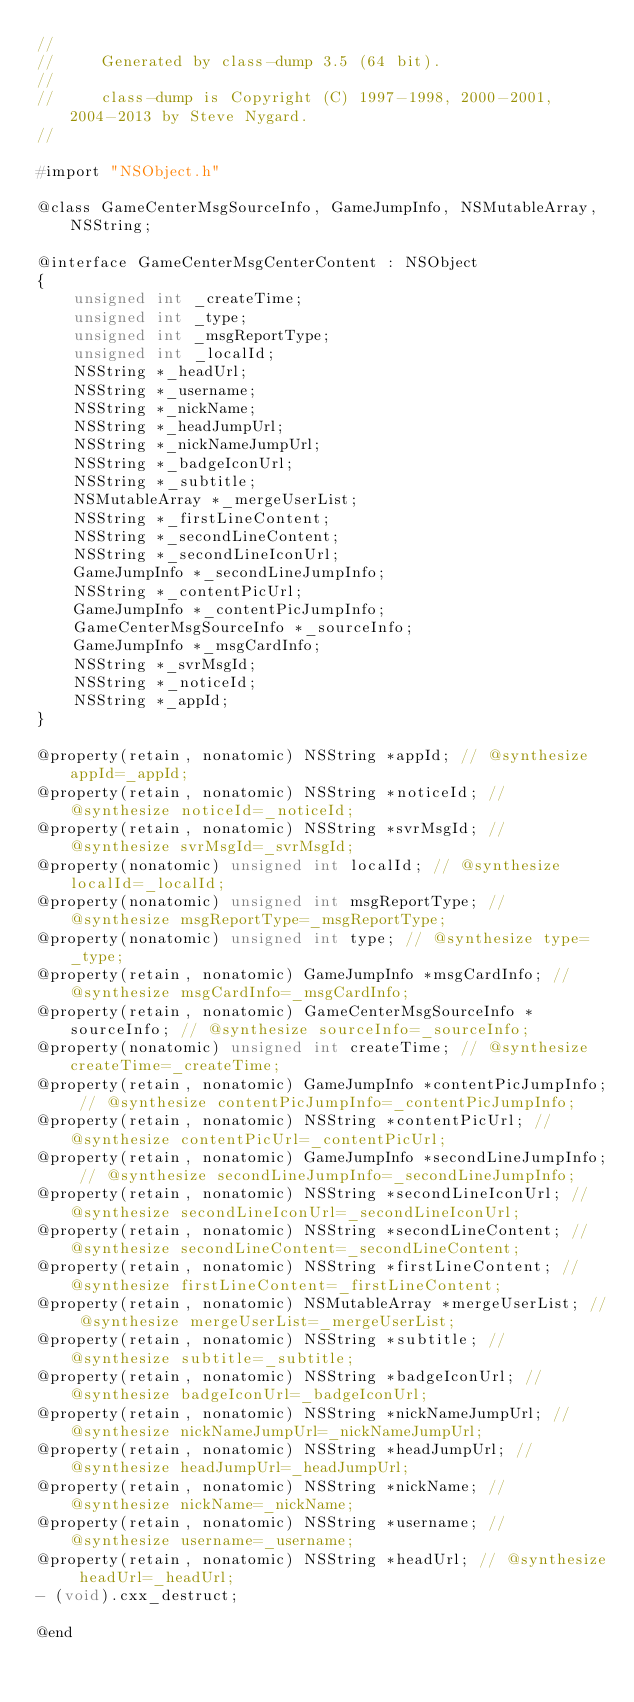<code> <loc_0><loc_0><loc_500><loc_500><_C_>//
//     Generated by class-dump 3.5 (64 bit).
//
//     class-dump is Copyright (C) 1997-1998, 2000-2001, 2004-2013 by Steve Nygard.
//

#import "NSObject.h"

@class GameCenterMsgSourceInfo, GameJumpInfo, NSMutableArray, NSString;

@interface GameCenterMsgCenterContent : NSObject
{
    unsigned int _createTime;
    unsigned int _type;
    unsigned int _msgReportType;
    unsigned int _localId;
    NSString *_headUrl;
    NSString *_username;
    NSString *_nickName;
    NSString *_headJumpUrl;
    NSString *_nickNameJumpUrl;
    NSString *_badgeIconUrl;
    NSString *_subtitle;
    NSMutableArray *_mergeUserList;
    NSString *_firstLineContent;
    NSString *_secondLineContent;
    NSString *_secondLineIconUrl;
    GameJumpInfo *_secondLineJumpInfo;
    NSString *_contentPicUrl;
    GameJumpInfo *_contentPicJumpInfo;
    GameCenterMsgSourceInfo *_sourceInfo;
    GameJumpInfo *_msgCardInfo;
    NSString *_svrMsgId;
    NSString *_noticeId;
    NSString *_appId;
}

@property(retain, nonatomic) NSString *appId; // @synthesize appId=_appId;
@property(retain, nonatomic) NSString *noticeId; // @synthesize noticeId=_noticeId;
@property(retain, nonatomic) NSString *svrMsgId; // @synthesize svrMsgId=_svrMsgId;
@property(nonatomic) unsigned int localId; // @synthesize localId=_localId;
@property(nonatomic) unsigned int msgReportType; // @synthesize msgReportType=_msgReportType;
@property(nonatomic) unsigned int type; // @synthesize type=_type;
@property(retain, nonatomic) GameJumpInfo *msgCardInfo; // @synthesize msgCardInfo=_msgCardInfo;
@property(retain, nonatomic) GameCenterMsgSourceInfo *sourceInfo; // @synthesize sourceInfo=_sourceInfo;
@property(nonatomic) unsigned int createTime; // @synthesize createTime=_createTime;
@property(retain, nonatomic) GameJumpInfo *contentPicJumpInfo; // @synthesize contentPicJumpInfo=_contentPicJumpInfo;
@property(retain, nonatomic) NSString *contentPicUrl; // @synthesize contentPicUrl=_contentPicUrl;
@property(retain, nonatomic) GameJumpInfo *secondLineJumpInfo; // @synthesize secondLineJumpInfo=_secondLineJumpInfo;
@property(retain, nonatomic) NSString *secondLineIconUrl; // @synthesize secondLineIconUrl=_secondLineIconUrl;
@property(retain, nonatomic) NSString *secondLineContent; // @synthesize secondLineContent=_secondLineContent;
@property(retain, nonatomic) NSString *firstLineContent; // @synthesize firstLineContent=_firstLineContent;
@property(retain, nonatomic) NSMutableArray *mergeUserList; // @synthesize mergeUserList=_mergeUserList;
@property(retain, nonatomic) NSString *subtitle; // @synthesize subtitle=_subtitle;
@property(retain, nonatomic) NSString *badgeIconUrl; // @synthesize badgeIconUrl=_badgeIconUrl;
@property(retain, nonatomic) NSString *nickNameJumpUrl; // @synthesize nickNameJumpUrl=_nickNameJumpUrl;
@property(retain, nonatomic) NSString *headJumpUrl; // @synthesize headJumpUrl=_headJumpUrl;
@property(retain, nonatomic) NSString *nickName; // @synthesize nickName=_nickName;
@property(retain, nonatomic) NSString *username; // @synthesize username=_username;
@property(retain, nonatomic) NSString *headUrl; // @synthesize headUrl=_headUrl;
- (void).cxx_destruct;

@end

</code> 